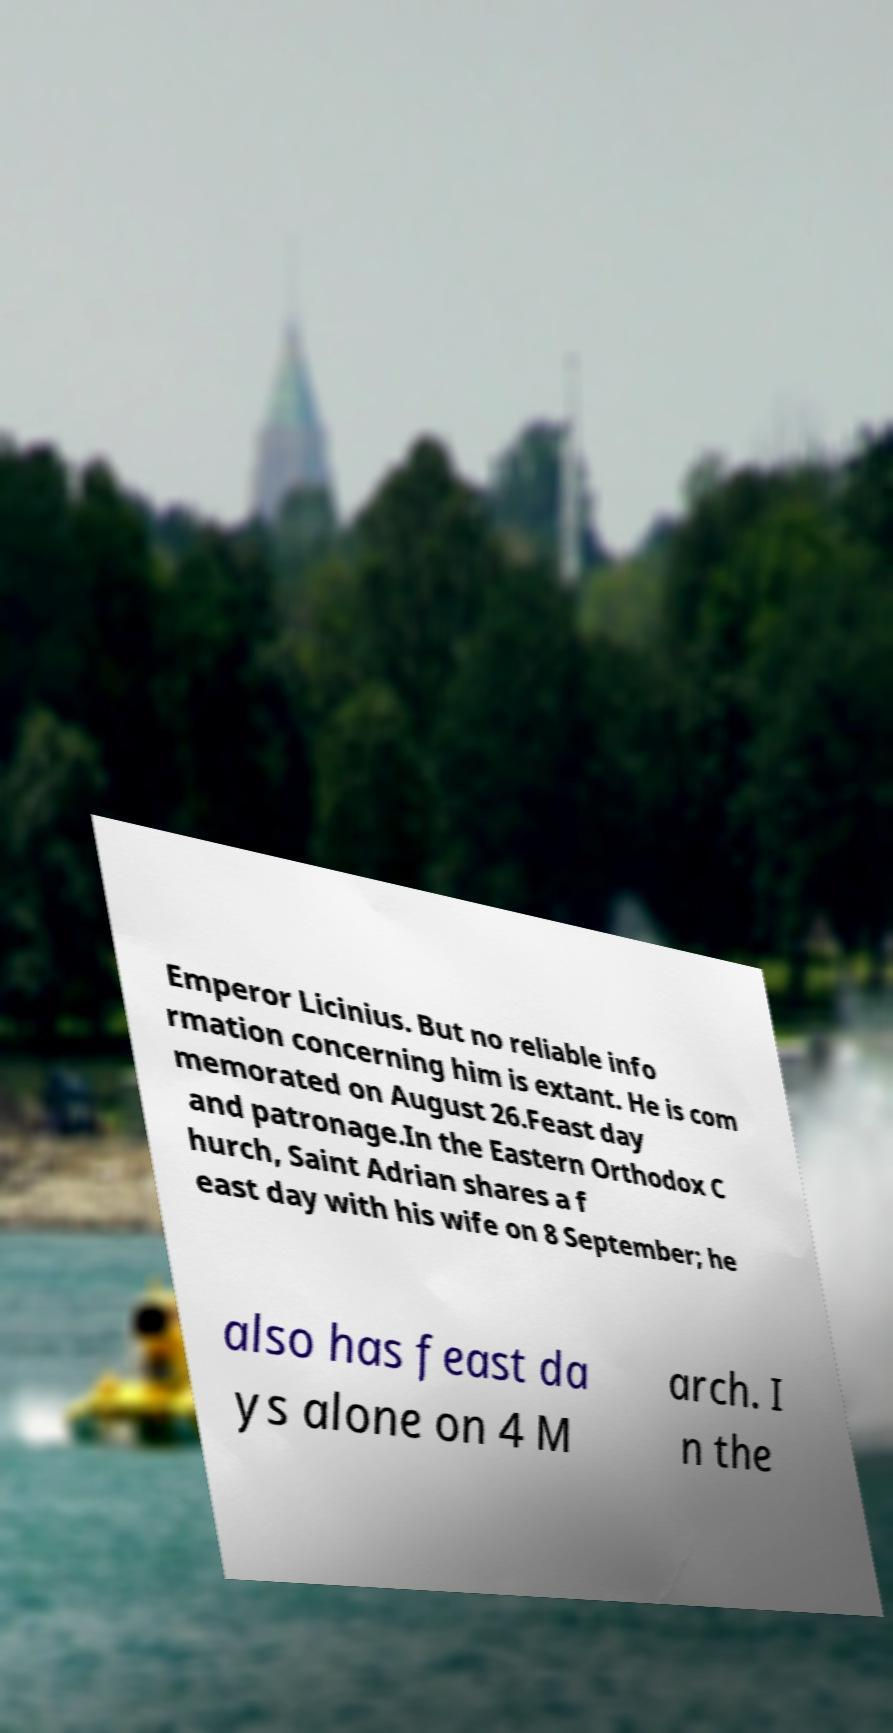There's text embedded in this image that I need extracted. Can you transcribe it verbatim? Emperor Licinius. But no reliable info rmation concerning him is extant. He is com memorated on August 26.Feast day and patronage.In the Eastern Orthodox C hurch, Saint Adrian shares a f east day with his wife on 8 September; he also has feast da ys alone on 4 M arch. I n the 